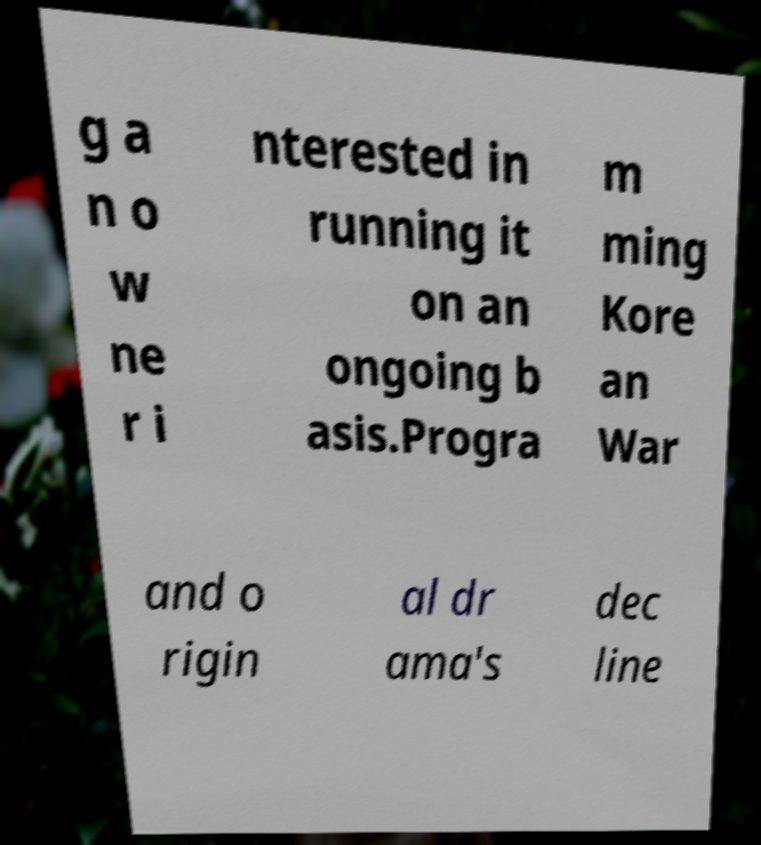Can you accurately transcribe the text from the provided image for me? g a n o w ne r i nterested in running it on an ongoing b asis.Progra m ming Kore an War and o rigin al dr ama's dec line 